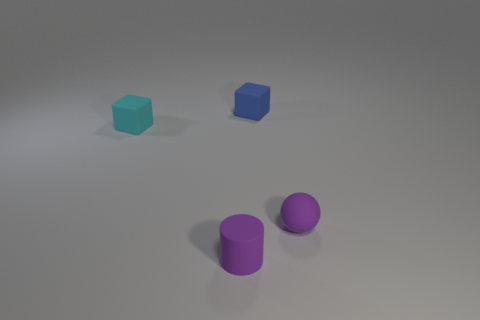Subtract all gray cubes. Subtract all purple cylinders. How many cubes are left? 2 Add 3 small cubes. How many objects exist? 7 Subtract all balls. How many objects are left? 3 Subtract 0 blue cylinders. How many objects are left? 4 Subtract all purple balls. Subtract all tiny rubber balls. How many objects are left? 2 Add 4 blue things. How many blue things are left? 5 Add 2 purple rubber things. How many purple rubber things exist? 4 